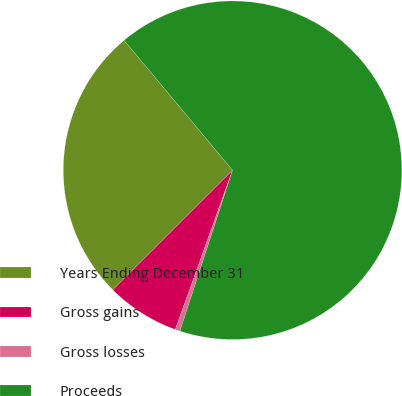Convert chart to OTSL. <chart><loc_0><loc_0><loc_500><loc_500><pie_chart><fcel>Years Ending December 31<fcel>Gross gains<fcel>Gross losses<fcel>Proceeds<nl><fcel>26.41%<fcel>7.02%<fcel>0.46%<fcel>66.11%<nl></chart> 